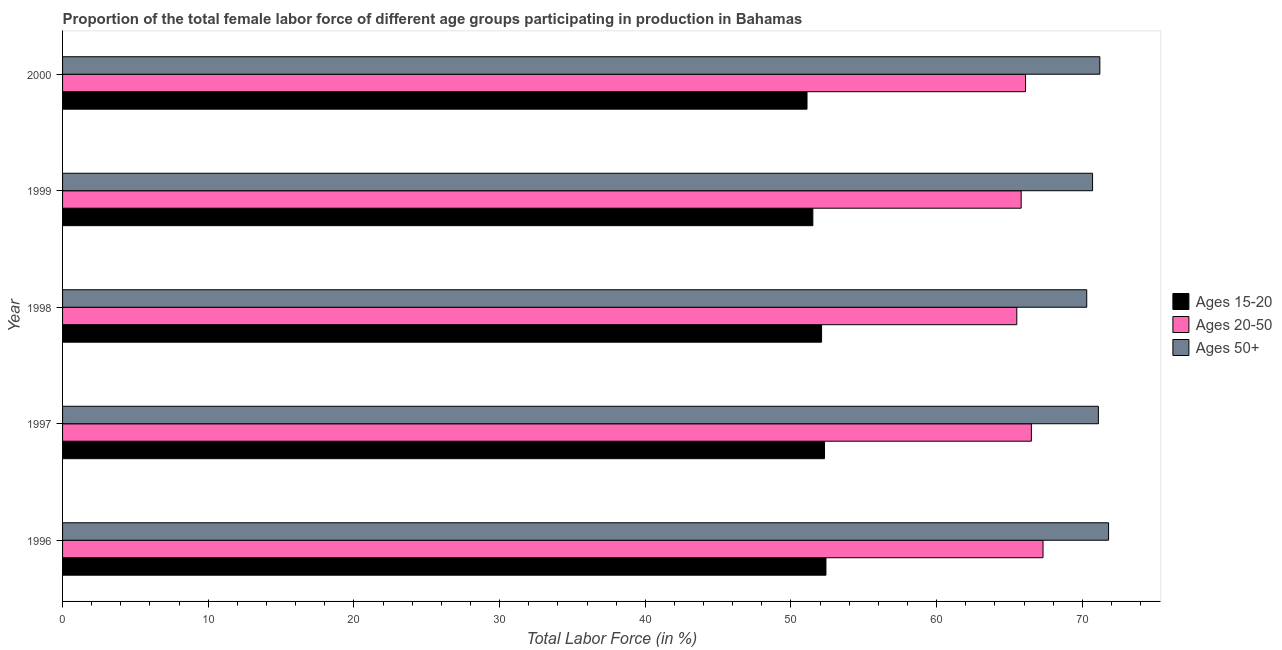How many different coloured bars are there?
Your answer should be very brief. 3. How many groups of bars are there?
Provide a short and direct response. 5. How many bars are there on the 2nd tick from the top?
Ensure brevity in your answer.  3. What is the percentage of female labor force within the age group 15-20 in 2000?
Ensure brevity in your answer.  51.1. Across all years, what is the maximum percentage of female labor force above age 50?
Give a very brief answer. 71.8. Across all years, what is the minimum percentage of female labor force above age 50?
Keep it short and to the point. 70.3. What is the total percentage of female labor force above age 50 in the graph?
Offer a very short reply. 355.1. What is the difference between the percentage of female labor force within the age group 15-20 in 1997 and the percentage of female labor force within the age group 20-50 in 1996?
Provide a short and direct response. -15. What is the average percentage of female labor force within the age group 15-20 per year?
Provide a short and direct response. 51.88. Is the difference between the percentage of female labor force above age 50 in 1997 and 1998 greater than the difference between the percentage of female labor force within the age group 15-20 in 1997 and 1998?
Provide a succinct answer. Yes. What does the 1st bar from the top in 1997 represents?
Keep it short and to the point. Ages 50+. What does the 1st bar from the bottom in 1996 represents?
Make the answer very short. Ages 15-20. How many bars are there?
Provide a succinct answer. 15. Are all the bars in the graph horizontal?
Provide a short and direct response. Yes. Does the graph contain any zero values?
Your answer should be compact. No. How many legend labels are there?
Give a very brief answer. 3. What is the title of the graph?
Provide a succinct answer. Proportion of the total female labor force of different age groups participating in production in Bahamas. What is the Total Labor Force (in %) of Ages 15-20 in 1996?
Your response must be concise. 52.4. What is the Total Labor Force (in %) in Ages 20-50 in 1996?
Ensure brevity in your answer.  67.3. What is the Total Labor Force (in %) in Ages 50+ in 1996?
Your response must be concise. 71.8. What is the Total Labor Force (in %) of Ages 15-20 in 1997?
Keep it short and to the point. 52.3. What is the Total Labor Force (in %) of Ages 20-50 in 1997?
Make the answer very short. 66.5. What is the Total Labor Force (in %) of Ages 50+ in 1997?
Your answer should be compact. 71.1. What is the Total Labor Force (in %) of Ages 15-20 in 1998?
Your answer should be compact. 52.1. What is the Total Labor Force (in %) in Ages 20-50 in 1998?
Offer a very short reply. 65.5. What is the Total Labor Force (in %) in Ages 50+ in 1998?
Your answer should be compact. 70.3. What is the Total Labor Force (in %) of Ages 15-20 in 1999?
Make the answer very short. 51.5. What is the Total Labor Force (in %) in Ages 20-50 in 1999?
Make the answer very short. 65.8. What is the Total Labor Force (in %) in Ages 50+ in 1999?
Provide a short and direct response. 70.7. What is the Total Labor Force (in %) in Ages 15-20 in 2000?
Ensure brevity in your answer.  51.1. What is the Total Labor Force (in %) of Ages 20-50 in 2000?
Offer a terse response. 66.1. What is the Total Labor Force (in %) in Ages 50+ in 2000?
Your answer should be compact. 71.2. Across all years, what is the maximum Total Labor Force (in %) of Ages 15-20?
Give a very brief answer. 52.4. Across all years, what is the maximum Total Labor Force (in %) in Ages 20-50?
Provide a short and direct response. 67.3. Across all years, what is the maximum Total Labor Force (in %) of Ages 50+?
Offer a terse response. 71.8. Across all years, what is the minimum Total Labor Force (in %) of Ages 15-20?
Keep it short and to the point. 51.1. Across all years, what is the minimum Total Labor Force (in %) in Ages 20-50?
Your response must be concise. 65.5. Across all years, what is the minimum Total Labor Force (in %) of Ages 50+?
Ensure brevity in your answer.  70.3. What is the total Total Labor Force (in %) in Ages 15-20 in the graph?
Keep it short and to the point. 259.4. What is the total Total Labor Force (in %) in Ages 20-50 in the graph?
Your answer should be compact. 331.2. What is the total Total Labor Force (in %) of Ages 50+ in the graph?
Provide a short and direct response. 355.1. What is the difference between the Total Labor Force (in %) in Ages 15-20 in 1996 and that in 1997?
Ensure brevity in your answer.  0.1. What is the difference between the Total Labor Force (in %) in Ages 20-50 in 1996 and that in 1997?
Keep it short and to the point. 0.8. What is the difference between the Total Labor Force (in %) of Ages 50+ in 1996 and that in 1997?
Keep it short and to the point. 0.7. What is the difference between the Total Labor Force (in %) of Ages 15-20 in 1996 and that in 1998?
Your answer should be very brief. 0.3. What is the difference between the Total Labor Force (in %) of Ages 50+ in 1996 and that in 1998?
Offer a very short reply. 1.5. What is the difference between the Total Labor Force (in %) in Ages 20-50 in 1996 and that in 1999?
Your answer should be very brief. 1.5. What is the difference between the Total Labor Force (in %) of Ages 50+ in 1996 and that in 1999?
Make the answer very short. 1.1. What is the difference between the Total Labor Force (in %) of Ages 20-50 in 1996 and that in 2000?
Keep it short and to the point. 1.2. What is the difference between the Total Labor Force (in %) of Ages 20-50 in 1997 and that in 1998?
Make the answer very short. 1. What is the difference between the Total Labor Force (in %) in Ages 50+ in 1997 and that in 1998?
Offer a very short reply. 0.8. What is the difference between the Total Labor Force (in %) in Ages 20-50 in 1997 and that in 1999?
Your response must be concise. 0.7. What is the difference between the Total Labor Force (in %) of Ages 50+ in 1997 and that in 1999?
Provide a succinct answer. 0.4. What is the difference between the Total Labor Force (in %) in Ages 15-20 in 1997 and that in 2000?
Your answer should be compact. 1.2. What is the difference between the Total Labor Force (in %) of Ages 20-50 in 1997 and that in 2000?
Your answer should be compact. 0.4. What is the difference between the Total Labor Force (in %) of Ages 20-50 in 1998 and that in 2000?
Provide a succinct answer. -0.6. What is the difference between the Total Labor Force (in %) in Ages 50+ in 1998 and that in 2000?
Provide a succinct answer. -0.9. What is the difference between the Total Labor Force (in %) of Ages 15-20 in 1999 and that in 2000?
Your answer should be compact. 0.4. What is the difference between the Total Labor Force (in %) of Ages 20-50 in 1999 and that in 2000?
Offer a terse response. -0.3. What is the difference between the Total Labor Force (in %) of Ages 50+ in 1999 and that in 2000?
Offer a terse response. -0.5. What is the difference between the Total Labor Force (in %) of Ages 15-20 in 1996 and the Total Labor Force (in %) of Ages 20-50 in 1997?
Your response must be concise. -14.1. What is the difference between the Total Labor Force (in %) in Ages 15-20 in 1996 and the Total Labor Force (in %) in Ages 50+ in 1997?
Give a very brief answer. -18.7. What is the difference between the Total Labor Force (in %) of Ages 15-20 in 1996 and the Total Labor Force (in %) of Ages 20-50 in 1998?
Keep it short and to the point. -13.1. What is the difference between the Total Labor Force (in %) of Ages 15-20 in 1996 and the Total Labor Force (in %) of Ages 50+ in 1998?
Offer a very short reply. -17.9. What is the difference between the Total Labor Force (in %) of Ages 20-50 in 1996 and the Total Labor Force (in %) of Ages 50+ in 1998?
Keep it short and to the point. -3. What is the difference between the Total Labor Force (in %) of Ages 15-20 in 1996 and the Total Labor Force (in %) of Ages 50+ in 1999?
Offer a very short reply. -18.3. What is the difference between the Total Labor Force (in %) of Ages 15-20 in 1996 and the Total Labor Force (in %) of Ages 20-50 in 2000?
Keep it short and to the point. -13.7. What is the difference between the Total Labor Force (in %) in Ages 15-20 in 1996 and the Total Labor Force (in %) in Ages 50+ in 2000?
Your answer should be very brief. -18.8. What is the difference between the Total Labor Force (in %) in Ages 15-20 in 1997 and the Total Labor Force (in %) in Ages 50+ in 1998?
Offer a very short reply. -18. What is the difference between the Total Labor Force (in %) of Ages 20-50 in 1997 and the Total Labor Force (in %) of Ages 50+ in 1998?
Keep it short and to the point. -3.8. What is the difference between the Total Labor Force (in %) in Ages 15-20 in 1997 and the Total Labor Force (in %) in Ages 20-50 in 1999?
Provide a short and direct response. -13.5. What is the difference between the Total Labor Force (in %) in Ages 15-20 in 1997 and the Total Labor Force (in %) in Ages 50+ in 1999?
Offer a terse response. -18.4. What is the difference between the Total Labor Force (in %) of Ages 15-20 in 1997 and the Total Labor Force (in %) of Ages 50+ in 2000?
Make the answer very short. -18.9. What is the difference between the Total Labor Force (in %) in Ages 15-20 in 1998 and the Total Labor Force (in %) in Ages 20-50 in 1999?
Your answer should be very brief. -13.7. What is the difference between the Total Labor Force (in %) of Ages 15-20 in 1998 and the Total Labor Force (in %) of Ages 50+ in 1999?
Your response must be concise. -18.6. What is the difference between the Total Labor Force (in %) of Ages 15-20 in 1998 and the Total Labor Force (in %) of Ages 50+ in 2000?
Provide a short and direct response. -19.1. What is the difference between the Total Labor Force (in %) in Ages 20-50 in 1998 and the Total Labor Force (in %) in Ages 50+ in 2000?
Keep it short and to the point. -5.7. What is the difference between the Total Labor Force (in %) of Ages 15-20 in 1999 and the Total Labor Force (in %) of Ages 20-50 in 2000?
Provide a short and direct response. -14.6. What is the difference between the Total Labor Force (in %) in Ages 15-20 in 1999 and the Total Labor Force (in %) in Ages 50+ in 2000?
Ensure brevity in your answer.  -19.7. What is the difference between the Total Labor Force (in %) in Ages 20-50 in 1999 and the Total Labor Force (in %) in Ages 50+ in 2000?
Make the answer very short. -5.4. What is the average Total Labor Force (in %) of Ages 15-20 per year?
Offer a very short reply. 51.88. What is the average Total Labor Force (in %) in Ages 20-50 per year?
Your response must be concise. 66.24. What is the average Total Labor Force (in %) of Ages 50+ per year?
Provide a short and direct response. 71.02. In the year 1996, what is the difference between the Total Labor Force (in %) of Ages 15-20 and Total Labor Force (in %) of Ages 20-50?
Make the answer very short. -14.9. In the year 1996, what is the difference between the Total Labor Force (in %) of Ages 15-20 and Total Labor Force (in %) of Ages 50+?
Your response must be concise. -19.4. In the year 1996, what is the difference between the Total Labor Force (in %) in Ages 20-50 and Total Labor Force (in %) in Ages 50+?
Provide a succinct answer. -4.5. In the year 1997, what is the difference between the Total Labor Force (in %) of Ages 15-20 and Total Labor Force (in %) of Ages 50+?
Your answer should be compact. -18.8. In the year 1997, what is the difference between the Total Labor Force (in %) of Ages 20-50 and Total Labor Force (in %) of Ages 50+?
Keep it short and to the point. -4.6. In the year 1998, what is the difference between the Total Labor Force (in %) of Ages 15-20 and Total Labor Force (in %) of Ages 20-50?
Offer a terse response. -13.4. In the year 1998, what is the difference between the Total Labor Force (in %) of Ages 15-20 and Total Labor Force (in %) of Ages 50+?
Your answer should be compact. -18.2. In the year 1999, what is the difference between the Total Labor Force (in %) in Ages 15-20 and Total Labor Force (in %) in Ages 20-50?
Ensure brevity in your answer.  -14.3. In the year 1999, what is the difference between the Total Labor Force (in %) in Ages 15-20 and Total Labor Force (in %) in Ages 50+?
Ensure brevity in your answer.  -19.2. In the year 1999, what is the difference between the Total Labor Force (in %) in Ages 20-50 and Total Labor Force (in %) in Ages 50+?
Your answer should be very brief. -4.9. In the year 2000, what is the difference between the Total Labor Force (in %) of Ages 15-20 and Total Labor Force (in %) of Ages 50+?
Ensure brevity in your answer.  -20.1. What is the ratio of the Total Labor Force (in %) in Ages 15-20 in 1996 to that in 1997?
Your response must be concise. 1. What is the ratio of the Total Labor Force (in %) of Ages 50+ in 1996 to that in 1997?
Provide a short and direct response. 1.01. What is the ratio of the Total Labor Force (in %) of Ages 15-20 in 1996 to that in 1998?
Keep it short and to the point. 1.01. What is the ratio of the Total Labor Force (in %) in Ages 20-50 in 1996 to that in 1998?
Offer a terse response. 1.03. What is the ratio of the Total Labor Force (in %) of Ages 50+ in 1996 to that in 1998?
Your answer should be very brief. 1.02. What is the ratio of the Total Labor Force (in %) in Ages 15-20 in 1996 to that in 1999?
Offer a very short reply. 1.02. What is the ratio of the Total Labor Force (in %) of Ages 20-50 in 1996 to that in 1999?
Give a very brief answer. 1.02. What is the ratio of the Total Labor Force (in %) in Ages 50+ in 1996 to that in 1999?
Keep it short and to the point. 1.02. What is the ratio of the Total Labor Force (in %) of Ages 15-20 in 1996 to that in 2000?
Keep it short and to the point. 1.03. What is the ratio of the Total Labor Force (in %) in Ages 20-50 in 1996 to that in 2000?
Ensure brevity in your answer.  1.02. What is the ratio of the Total Labor Force (in %) in Ages 50+ in 1996 to that in 2000?
Ensure brevity in your answer.  1.01. What is the ratio of the Total Labor Force (in %) in Ages 20-50 in 1997 to that in 1998?
Offer a very short reply. 1.02. What is the ratio of the Total Labor Force (in %) of Ages 50+ in 1997 to that in 1998?
Keep it short and to the point. 1.01. What is the ratio of the Total Labor Force (in %) of Ages 15-20 in 1997 to that in 1999?
Your answer should be compact. 1.02. What is the ratio of the Total Labor Force (in %) of Ages 20-50 in 1997 to that in 1999?
Offer a very short reply. 1.01. What is the ratio of the Total Labor Force (in %) in Ages 50+ in 1997 to that in 1999?
Give a very brief answer. 1.01. What is the ratio of the Total Labor Force (in %) of Ages 15-20 in 1997 to that in 2000?
Offer a terse response. 1.02. What is the ratio of the Total Labor Force (in %) in Ages 20-50 in 1997 to that in 2000?
Provide a short and direct response. 1.01. What is the ratio of the Total Labor Force (in %) of Ages 15-20 in 1998 to that in 1999?
Keep it short and to the point. 1.01. What is the ratio of the Total Labor Force (in %) of Ages 20-50 in 1998 to that in 1999?
Offer a very short reply. 1. What is the ratio of the Total Labor Force (in %) of Ages 50+ in 1998 to that in 1999?
Provide a succinct answer. 0.99. What is the ratio of the Total Labor Force (in %) of Ages 15-20 in 1998 to that in 2000?
Offer a terse response. 1.02. What is the ratio of the Total Labor Force (in %) of Ages 20-50 in 1998 to that in 2000?
Keep it short and to the point. 0.99. What is the ratio of the Total Labor Force (in %) in Ages 50+ in 1998 to that in 2000?
Your answer should be compact. 0.99. What is the ratio of the Total Labor Force (in %) of Ages 20-50 in 1999 to that in 2000?
Your response must be concise. 1. What is the difference between the highest and the second highest Total Labor Force (in %) in Ages 20-50?
Ensure brevity in your answer.  0.8. What is the difference between the highest and the lowest Total Labor Force (in %) in Ages 15-20?
Offer a terse response. 1.3. 